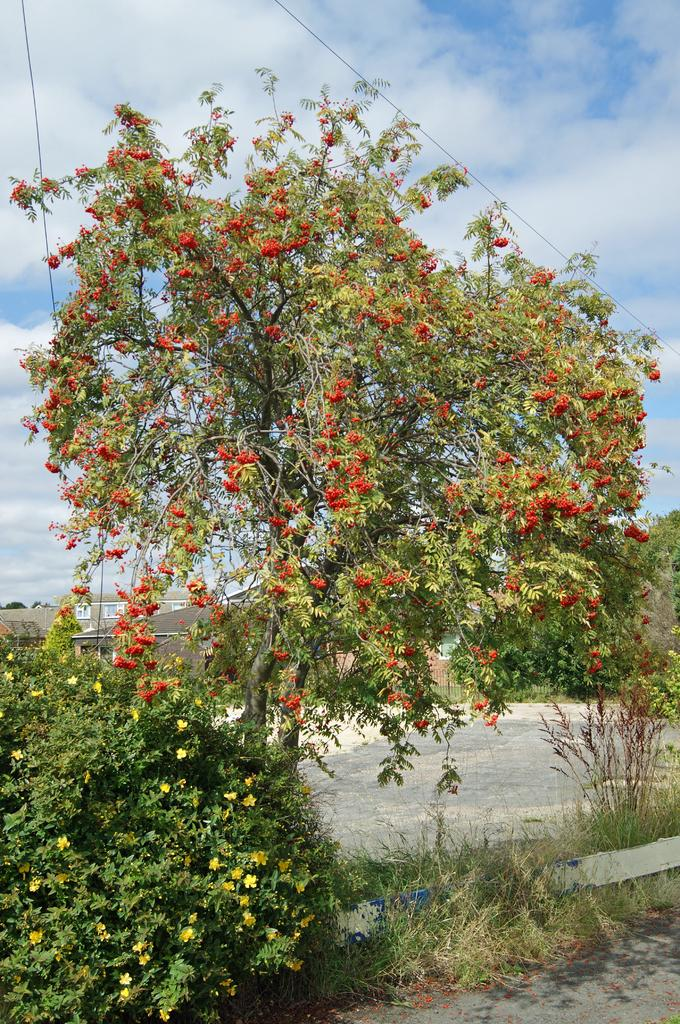What type of vegetation can be seen in the image? There are plants, trees, and flowers in the image. What is visible on the ground in the image? The ground is visible in the image. What is visible in the sky in the image? The sky is visible in the image, and clouds are present. Can you see your partner taking a bath in the ocean in the image? There is no partner, bath, or ocean present in the image. 